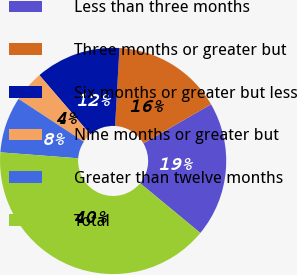Convert chart. <chart><loc_0><loc_0><loc_500><loc_500><pie_chart><fcel>Less than three months<fcel>Three months or greater but<fcel>Six months or greater but less<fcel>Nine months or greater but<fcel>Greater than twelve months<fcel>Total<nl><fcel>19.33%<fcel>15.76%<fcel>12.19%<fcel>4.46%<fcel>8.03%<fcel>40.22%<nl></chart> 